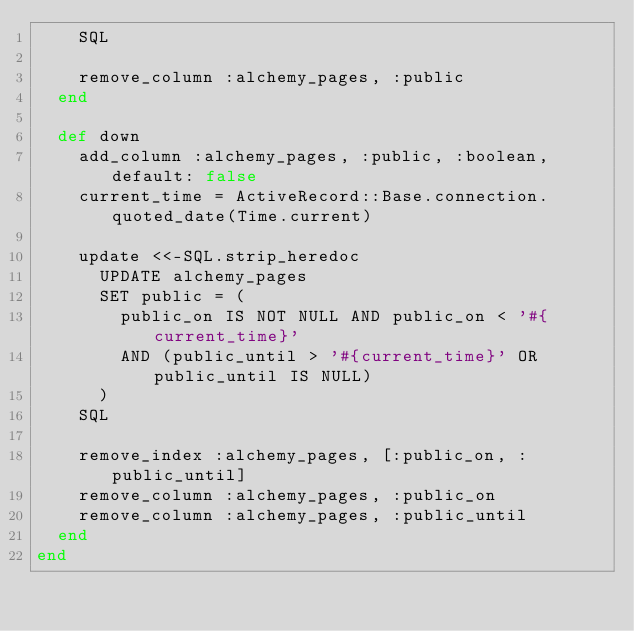Convert code to text. <code><loc_0><loc_0><loc_500><loc_500><_Ruby_>    SQL

    remove_column :alchemy_pages, :public
  end

  def down
    add_column :alchemy_pages, :public, :boolean, default: false
    current_time = ActiveRecord::Base.connection.quoted_date(Time.current)

    update <<-SQL.strip_heredoc
      UPDATE alchemy_pages
      SET public = (
        public_on IS NOT NULL AND public_on < '#{current_time}'
        AND (public_until > '#{current_time}' OR public_until IS NULL)
      )
    SQL

    remove_index :alchemy_pages, [:public_on, :public_until]
    remove_column :alchemy_pages, :public_on
    remove_column :alchemy_pages, :public_until
  end
end
</code> 